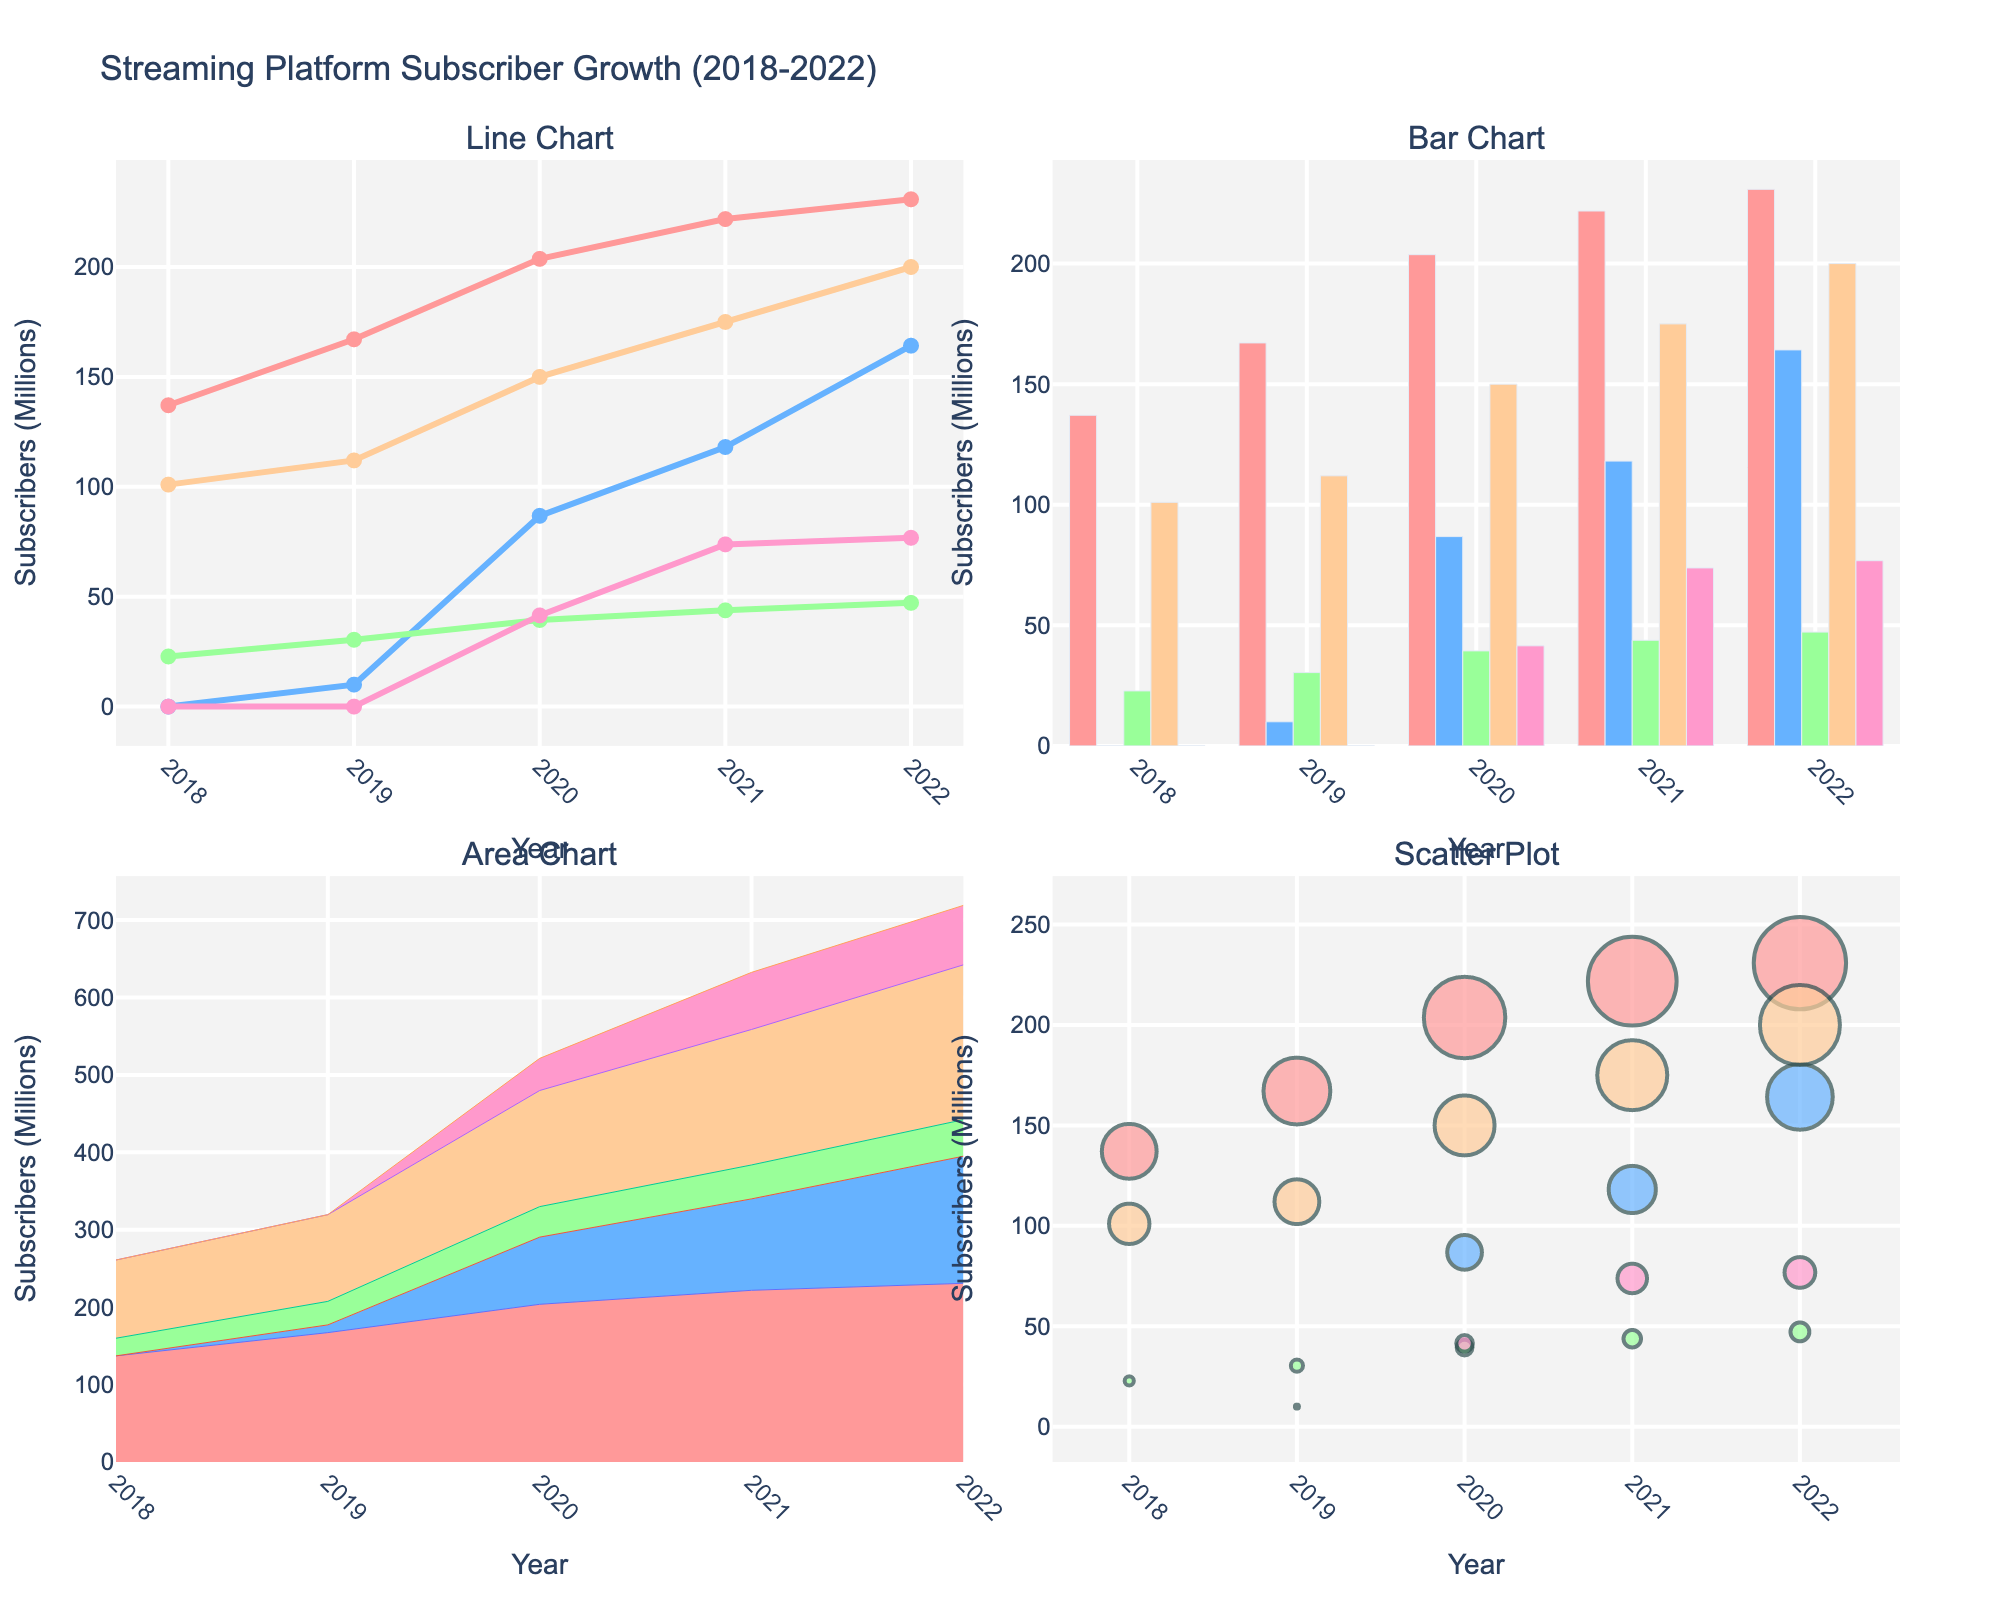What's the title of the figure? The title is usually displayed at the top of the figure. It mentions the context of the figure, which in this case is the growth of streaming platform subscribers over the years.
Answer: "Streaming Platform Subscriber Growth (2018-2022)" How many subplot titles are there? There are usually titles above each subplot, and according to the code, there should be four different subplot titles.
Answer: 4 Which streaming service had the highest number of subscribers in 2020 according to the Line Chart? By examining the Line Chart, look at the data points for the year 2020 and compare the values for Netflix, Disney+, Hulu, Amazon Prime Video, and HBO Max.
Answer: Netflix What color represents HBO Max across all subplots? The color used for each service is consistent across subplots. HBO Max is the last platform in the code and corresponds to the fifth color in the list.
Answer: Pink What's the average number of subscribers for Disney+ from 2018 to 2022? Add the number of Disney+ subscribers from each year and divide by the number of years (5). (0 + 10.0 + 86.8 + 118.1 + 164.2) / 5 = 75.82
Answer: 75.82 million Which service shows continuous growth across all years in the Bar Chart? Observe the height of the bars for each service across the years. The service with bars always increasing in height indicates continuous growth.
Answer: Amazon Prime Video By how much did Hulu's subscribers increase from 2018 to 2022 in the Area Chart? Subtract Hulu’s subscribers in 2018 from those in 2022 (47.2 - 22.8).
Answer: 24.4 million In the Scatter Plot, which streaming service has the smallest markers in 2018? In the Scatter Plot, the size of the marker varies with the number of subscribers. The service with the smallest value in 2018 will have the smallest marker.
Answer: Disney+ Between 2021 and 2022, which streaming service saw the largest absolute increase in subscribers according to the Line Chart? Calculate the difference in subscribers for each service between 2021 and 2022 and compare. Disney+ increased from 118.1 to 164.2 (46.1 million), which is the largest increase among the services.
Answer: Disney+ Which subplot illustrates the cumulative effect of all streaming services on the total number of subscribers over the years? The Area Chart is effective at showing the cumulative value by stacking the areas for each service.
Answer: Area Chart 